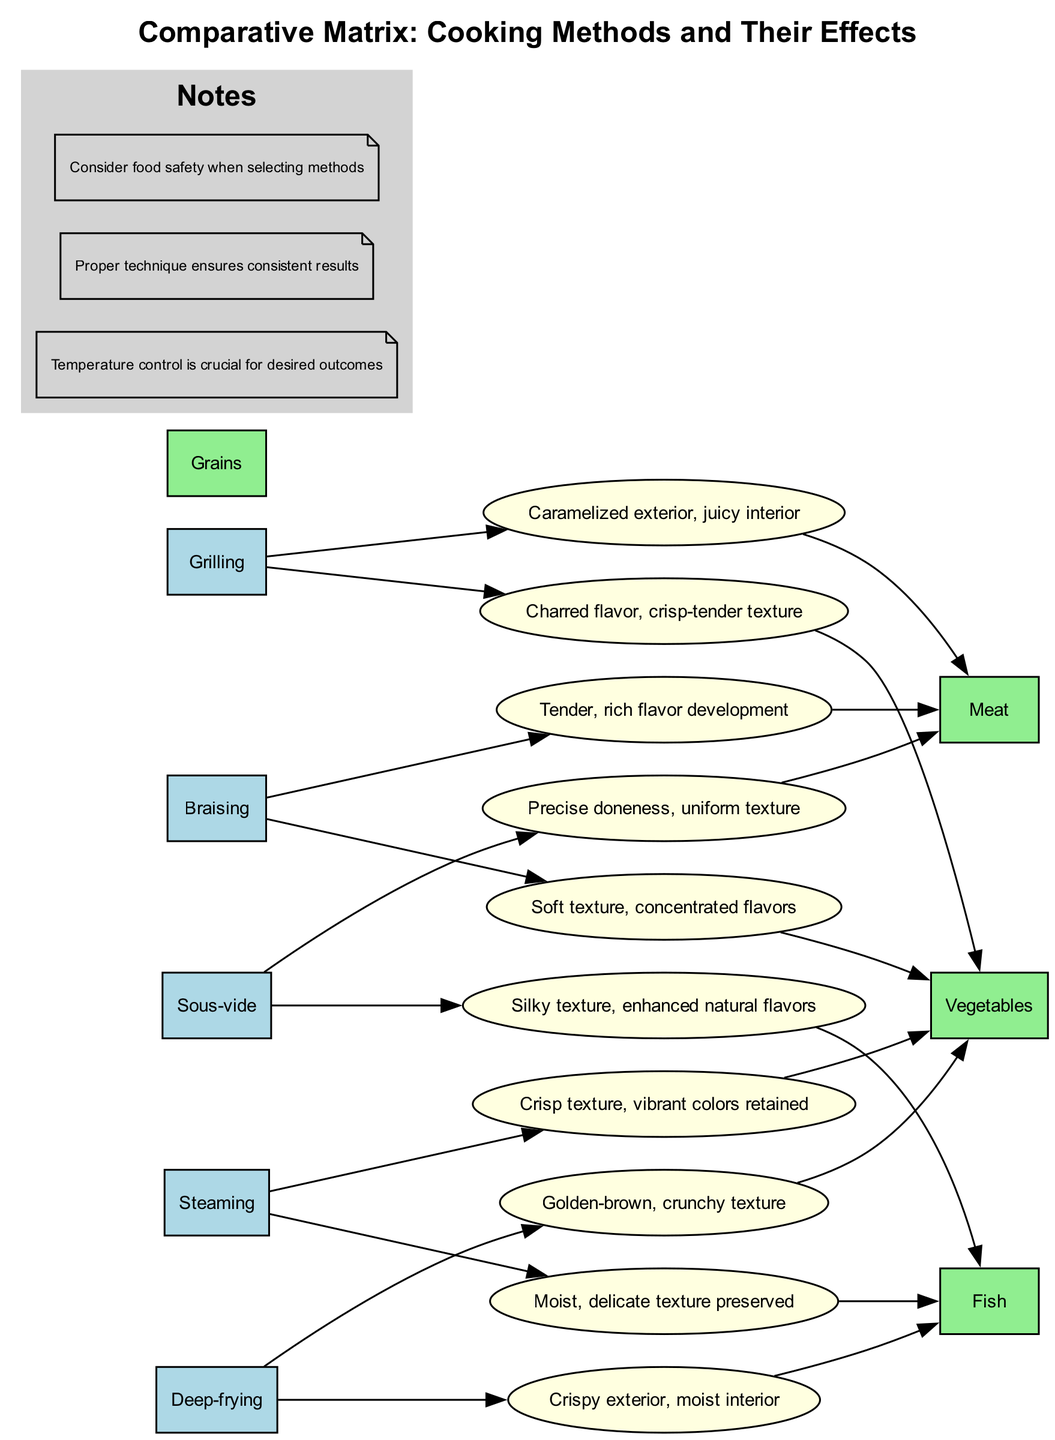What is the effect of grilling on meat? The diagram shows that grilling results in a caramelized exterior and juicy interior for meat. This information is found under the "Grilling" row and "Meat" column.
Answer: Caramelized exterior, juicy interior How many cooking methods are listed in the diagram? The diagram lists five cooking methods: Grilling, Braising, Steaming, Deep-frying, and Sous-vide. Counting these gives a total of five methods.
Answer: 5 What is the effect of steaming on vegetables? According to the diagram, steaming vegetables results in a crisp texture and vibrant colors being retained. This can be found in the "Steaming" row and "Vegetables" column.
Answer: Crisp texture, vibrant colors retained Which cooking method leads to a soft texture in vegetables? The diagram indicates that braising results in a soft texture for vegetables. This information can be extracted from the "Braising" row and "Vegetables" column.
Answer: Soft texture How does sous-vide affect fish? The diagram shows that sous-vide results in a silky texture and enhances natural flavors of fish. This effect can be found in the "Sous-vide" row and "Fish" column.
Answer: Silky texture, enhanced natural flavors What is the combined effect of deep-frying on fish? The diagram indicates that deep-frying fish produces a crispy exterior and a moist interior. This information is located in the "Deep-frying" row and "Fish" column.
Answer: Crispy exterior, moist interior How many effects are listed for the braising method? The diagram specifies two effects for the braising method: one for meat (tender, rich flavor development) and one for vegetables (soft texture, concentrated flavors). Counting these results in a total of two effects.
Answer: 2 Which method is associated with precise doneness for meat? From the diagram, sous-vide is associated with a precise doneness and uniform texture for meat. This information can be found in the "Sous-vide" row and "Meat" column.
Answer: Sous-vide What is the effect of deep-frying on vegetables? The diagram illustrates that deep-frying vegetables leads to a golden-brown, crunchy texture. This effect appears under the "Deep-frying" row and "Vegetables" column.
Answer: Golden-brown, crunchy texture 